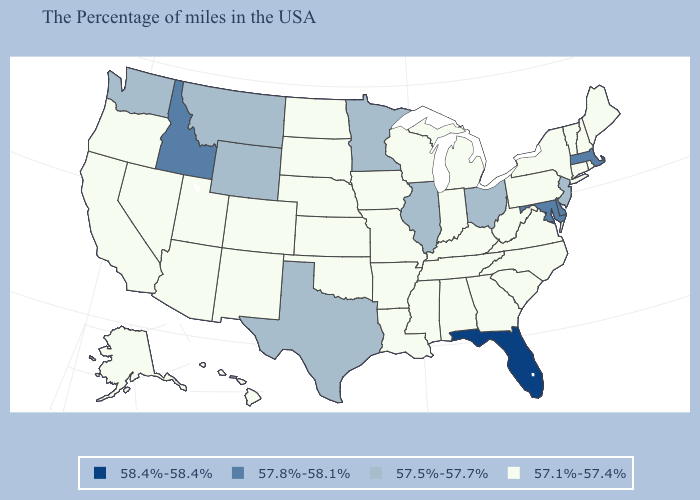Name the states that have a value in the range 57.1%-57.4%?
Give a very brief answer. Maine, Rhode Island, New Hampshire, Vermont, Connecticut, New York, Pennsylvania, Virginia, North Carolina, South Carolina, West Virginia, Georgia, Michigan, Kentucky, Indiana, Alabama, Tennessee, Wisconsin, Mississippi, Louisiana, Missouri, Arkansas, Iowa, Kansas, Nebraska, Oklahoma, South Dakota, North Dakota, Colorado, New Mexico, Utah, Arizona, Nevada, California, Oregon, Alaska, Hawaii. Name the states that have a value in the range 57.8%-58.1%?
Quick response, please. Massachusetts, Delaware, Maryland, Idaho. What is the value of Arizona?
Keep it brief. 57.1%-57.4%. Does the first symbol in the legend represent the smallest category?
Write a very short answer. No. What is the value of South Dakota?
Short answer required. 57.1%-57.4%. What is the value of Virginia?
Keep it brief. 57.1%-57.4%. Name the states that have a value in the range 57.5%-57.7%?
Keep it brief. New Jersey, Ohio, Illinois, Minnesota, Texas, Wyoming, Montana, Washington. Name the states that have a value in the range 58.4%-58.4%?
Give a very brief answer. Florida. How many symbols are there in the legend?
Quick response, please. 4. What is the highest value in states that border North Carolina?
Short answer required. 57.1%-57.4%. Which states have the highest value in the USA?
Quick response, please. Florida. Is the legend a continuous bar?
Concise answer only. No. Does Louisiana have the same value as West Virginia?
Give a very brief answer. Yes. What is the lowest value in the Northeast?
Keep it brief. 57.1%-57.4%. Among the states that border Kentucky , does Missouri have the highest value?
Keep it brief. No. 